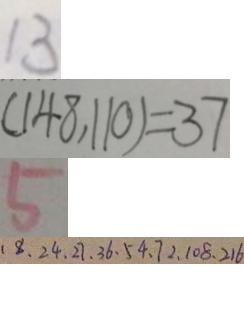<formula> <loc_0><loc_0><loc_500><loc_500>1 3 
 ( 1 4 8 , 1 1 0 ) = 3 7 
 5 
 1 8 、 2 4 、 2 7 、 3 6 、 5 4 、 7 2 、 1 0 8 、 2 1 6</formula> 